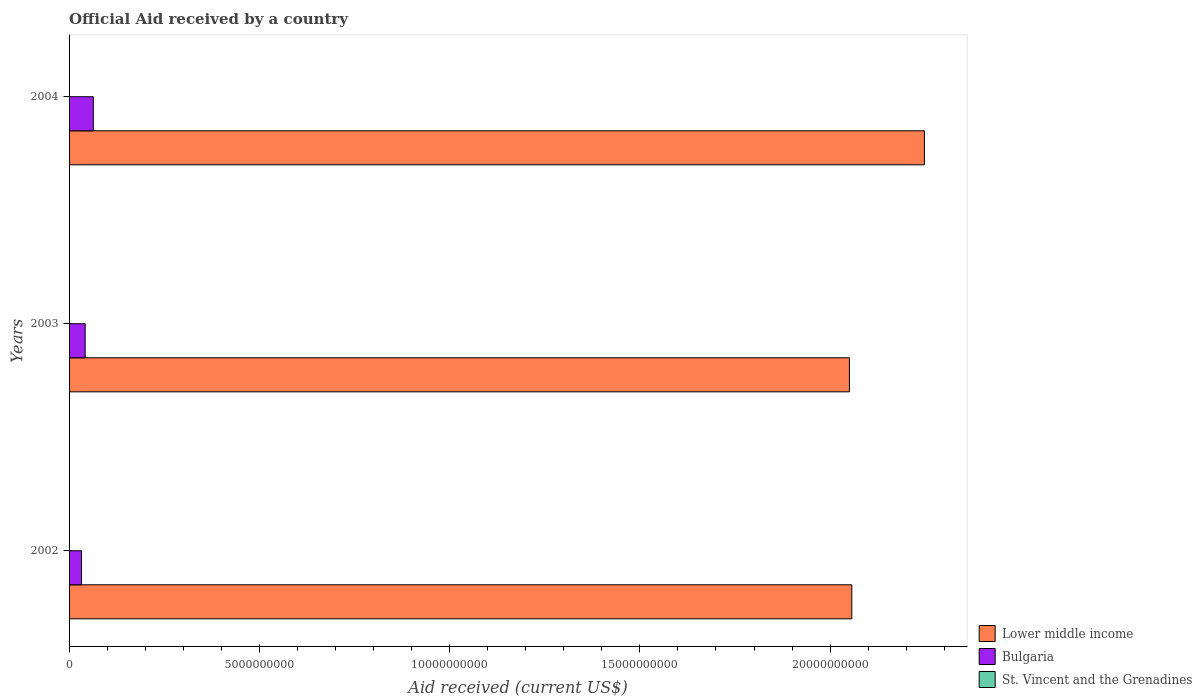How many different coloured bars are there?
Provide a short and direct response. 3. How many bars are there on the 1st tick from the top?
Ensure brevity in your answer.  3. What is the label of the 2nd group of bars from the top?
Your answer should be compact. 2003. In how many cases, is the number of bars for a given year not equal to the number of legend labels?
Provide a succinct answer. 0. What is the net official aid received in Bulgaria in 2004?
Your answer should be very brief. 6.37e+08. Across all years, what is the maximum net official aid received in St. Vincent and the Grenadines?
Provide a short and direct response. 1.06e+07. Across all years, what is the minimum net official aid received in St. Vincent and the Grenadines?
Provide a succinct answer. 4.57e+06. What is the total net official aid received in St. Vincent and the Grenadines in the graph?
Your response must be concise. 2.17e+07. What is the difference between the net official aid received in Bulgaria in 2002 and that in 2004?
Make the answer very short. -3.10e+08. What is the difference between the net official aid received in Lower middle income in 2003 and the net official aid received in St. Vincent and the Grenadines in 2002?
Your answer should be compact. 2.05e+1. What is the average net official aid received in Lower middle income per year?
Offer a terse response. 2.12e+1. In the year 2004, what is the difference between the net official aid received in Bulgaria and net official aid received in Lower middle income?
Give a very brief answer. -2.18e+1. What is the ratio of the net official aid received in Lower middle income in 2003 to that in 2004?
Offer a very short reply. 0.91. Is the net official aid received in Lower middle income in 2003 less than that in 2004?
Offer a terse response. Yes. Is the difference between the net official aid received in Bulgaria in 2003 and 2004 greater than the difference between the net official aid received in Lower middle income in 2003 and 2004?
Offer a very short reply. Yes. What is the difference between the highest and the second highest net official aid received in Lower middle income?
Make the answer very short. 1.91e+09. What is the difference between the highest and the lowest net official aid received in Lower middle income?
Offer a terse response. 1.97e+09. Is the sum of the net official aid received in St. Vincent and the Grenadines in 2002 and 2003 greater than the maximum net official aid received in Bulgaria across all years?
Offer a terse response. No. What does the 3rd bar from the top in 2003 represents?
Provide a succinct answer. Lower middle income. What does the 1st bar from the bottom in 2003 represents?
Keep it short and to the point. Lower middle income. Is it the case that in every year, the sum of the net official aid received in Bulgaria and net official aid received in St. Vincent and the Grenadines is greater than the net official aid received in Lower middle income?
Your answer should be compact. No. What is the difference between two consecutive major ticks on the X-axis?
Keep it short and to the point. 5.00e+09. Does the graph contain grids?
Keep it short and to the point. No. Where does the legend appear in the graph?
Make the answer very short. Bottom right. How many legend labels are there?
Keep it short and to the point. 3. How are the legend labels stacked?
Make the answer very short. Vertical. What is the title of the graph?
Offer a very short reply. Official Aid received by a country. What is the label or title of the X-axis?
Your answer should be compact. Aid received (current US$). What is the Aid received (current US$) of Lower middle income in 2002?
Offer a terse response. 2.06e+1. What is the Aid received (current US$) of Bulgaria in 2002?
Your answer should be very brief. 3.27e+08. What is the Aid received (current US$) in St. Vincent and the Grenadines in 2002?
Offer a very short reply. 4.57e+06. What is the Aid received (current US$) in Lower middle income in 2003?
Keep it short and to the point. 2.05e+1. What is the Aid received (current US$) of Bulgaria in 2003?
Your response must be concise. 4.23e+08. What is the Aid received (current US$) in St. Vincent and the Grenadines in 2003?
Offer a very short reply. 6.48e+06. What is the Aid received (current US$) in Lower middle income in 2004?
Offer a terse response. 2.25e+1. What is the Aid received (current US$) in Bulgaria in 2004?
Your response must be concise. 6.37e+08. What is the Aid received (current US$) in St. Vincent and the Grenadines in 2004?
Provide a short and direct response. 1.06e+07. Across all years, what is the maximum Aid received (current US$) of Lower middle income?
Offer a terse response. 2.25e+1. Across all years, what is the maximum Aid received (current US$) of Bulgaria?
Your answer should be very brief. 6.37e+08. Across all years, what is the maximum Aid received (current US$) of St. Vincent and the Grenadines?
Ensure brevity in your answer.  1.06e+07. Across all years, what is the minimum Aid received (current US$) in Lower middle income?
Offer a very short reply. 2.05e+1. Across all years, what is the minimum Aid received (current US$) of Bulgaria?
Provide a succinct answer. 3.27e+08. Across all years, what is the minimum Aid received (current US$) in St. Vincent and the Grenadines?
Make the answer very short. 4.57e+06. What is the total Aid received (current US$) of Lower middle income in the graph?
Offer a terse response. 6.36e+1. What is the total Aid received (current US$) of Bulgaria in the graph?
Give a very brief answer. 1.39e+09. What is the total Aid received (current US$) in St. Vincent and the Grenadines in the graph?
Your response must be concise. 2.17e+07. What is the difference between the Aid received (current US$) of Lower middle income in 2002 and that in 2003?
Make the answer very short. 6.30e+07. What is the difference between the Aid received (current US$) of Bulgaria in 2002 and that in 2003?
Make the answer very short. -9.62e+07. What is the difference between the Aid received (current US$) in St. Vincent and the Grenadines in 2002 and that in 2003?
Give a very brief answer. -1.91e+06. What is the difference between the Aid received (current US$) of Lower middle income in 2002 and that in 2004?
Provide a succinct answer. -1.91e+09. What is the difference between the Aid received (current US$) of Bulgaria in 2002 and that in 2004?
Make the answer very short. -3.10e+08. What is the difference between the Aid received (current US$) of St. Vincent and the Grenadines in 2002 and that in 2004?
Provide a short and direct response. -6.05e+06. What is the difference between the Aid received (current US$) in Lower middle income in 2003 and that in 2004?
Offer a terse response. -1.97e+09. What is the difference between the Aid received (current US$) of Bulgaria in 2003 and that in 2004?
Offer a very short reply. -2.13e+08. What is the difference between the Aid received (current US$) of St. Vincent and the Grenadines in 2003 and that in 2004?
Your answer should be very brief. -4.14e+06. What is the difference between the Aid received (current US$) of Lower middle income in 2002 and the Aid received (current US$) of Bulgaria in 2003?
Your answer should be compact. 2.01e+1. What is the difference between the Aid received (current US$) of Lower middle income in 2002 and the Aid received (current US$) of St. Vincent and the Grenadines in 2003?
Give a very brief answer. 2.06e+1. What is the difference between the Aid received (current US$) in Bulgaria in 2002 and the Aid received (current US$) in St. Vincent and the Grenadines in 2003?
Keep it short and to the point. 3.21e+08. What is the difference between the Aid received (current US$) of Lower middle income in 2002 and the Aid received (current US$) of Bulgaria in 2004?
Provide a short and direct response. 1.99e+1. What is the difference between the Aid received (current US$) of Lower middle income in 2002 and the Aid received (current US$) of St. Vincent and the Grenadines in 2004?
Your answer should be very brief. 2.06e+1. What is the difference between the Aid received (current US$) of Bulgaria in 2002 and the Aid received (current US$) of St. Vincent and the Grenadines in 2004?
Your response must be concise. 3.17e+08. What is the difference between the Aid received (current US$) of Lower middle income in 2003 and the Aid received (current US$) of Bulgaria in 2004?
Offer a terse response. 1.99e+1. What is the difference between the Aid received (current US$) in Lower middle income in 2003 and the Aid received (current US$) in St. Vincent and the Grenadines in 2004?
Your answer should be compact. 2.05e+1. What is the difference between the Aid received (current US$) of Bulgaria in 2003 and the Aid received (current US$) of St. Vincent and the Grenadines in 2004?
Your answer should be very brief. 4.13e+08. What is the average Aid received (current US$) in Lower middle income per year?
Offer a very short reply. 2.12e+1. What is the average Aid received (current US$) in Bulgaria per year?
Keep it short and to the point. 4.62e+08. What is the average Aid received (current US$) in St. Vincent and the Grenadines per year?
Provide a succinct answer. 7.22e+06. In the year 2002, what is the difference between the Aid received (current US$) in Lower middle income and Aid received (current US$) in Bulgaria?
Your response must be concise. 2.02e+1. In the year 2002, what is the difference between the Aid received (current US$) of Lower middle income and Aid received (current US$) of St. Vincent and the Grenadines?
Give a very brief answer. 2.06e+1. In the year 2002, what is the difference between the Aid received (current US$) in Bulgaria and Aid received (current US$) in St. Vincent and the Grenadines?
Provide a short and direct response. 3.23e+08. In the year 2003, what is the difference between the Aid received (current US$) of Lower middle income and Aid received (current US$) of Bulgaria?
Provide a short and direct response. 2.01e+1. In the year 2003, what is the difference between the Aid received (current US$) in Lower middle income and Aid received (current US$) in St. Vincent and the Grenadines?
Offer a very short reply. 2.05e+1. In the year 2003, what is the difference between the Aid received (current US$) in Bulgaria and Aid received (current US$) in St. Vincent and the Grenadines?
Give a very brief answer. 4.17e+08. In the year 2004, what is the difference between the Aid received (current US$) of Lower middle income and Aid received (current US$) of Bulgaria?
Offer a very short reply. 2.18e+1. In the year 2004, what is the difference between the Aid received (current US$) of Lower middle income and Aid received (current US$) of St. Vincent and the Grenadines?
Make the answer very short. 2.25e+1. In the year 2004, what is the difference between the Aid received (current US$) of Bulgaria and Aid received (current US$) of St. Vincent and the Grenadines?
Provide a succinct answer. 6.26e+08. What is the ratio of the Aid received (current US$) in Bulgaria in 2002 to that in 2003?
Make the answer very short. 0.77. What is the ratio of the Aid received (current US$) in St. Vincent and the Grenadines in 2002 to that in 2003?
Your answer should be very brief. 0.71. What is the ratio of the Aid received (current US$) in Lower middle income in 2002 to that in 2004?
Your answer should be compact. 0.92. What is the ratio of the Aid received (current US$) of Bulgaria in 2002 to that in 2004?
Keep it short and to the point. 0.51. What is the ratio of the Aid received (current US$) of St. Vincent and the Grenadines in 2002 to that in 2004?
Your response must be concise. 0.43. What is the ratio of the Aid received (current US$) in Lower middle income in 2003 to that in 2004?
Offer a terse response. 0.91. What is the ratio of the Aid received (current US$) in Bulgaria in 2003 to that in 2004?
Give a very brief answer. 0.67. What is the ratio of the Aid received (current US$) in St. Vincent and the Grenadines in 2003 to that in 2004?
Make the answer very short. 0.61. What is the difference between the highest and the second highest Aid received (current US$) of Lower middle income?
Ensure brevity in your answer.  1.91e+09. What is the difference between the highest and the second highest Aid received (current US$) of Bulgaria?
Make the answer very short. 2.13e+08. What is the difference between the highest and the second highest Aid received (current US$) in St. Vincent and the Grenadines?
Provide a succinct answer. 4.14e+06. What is the difference between the highest and the lowest Aid received (current US$) in Lower middle income?
Keep it short and to the point. 1.97e+09. What is the difference between the highest and the lowest Aid received (current US$) of Bulgaria?
Keep it short and to the point. 3.10e+08. What is the difference between the highest and the lowest Aid received (current US$) in St. Vincent and the Grenadines?
Your answer should be very brief. 6.05e+06. 